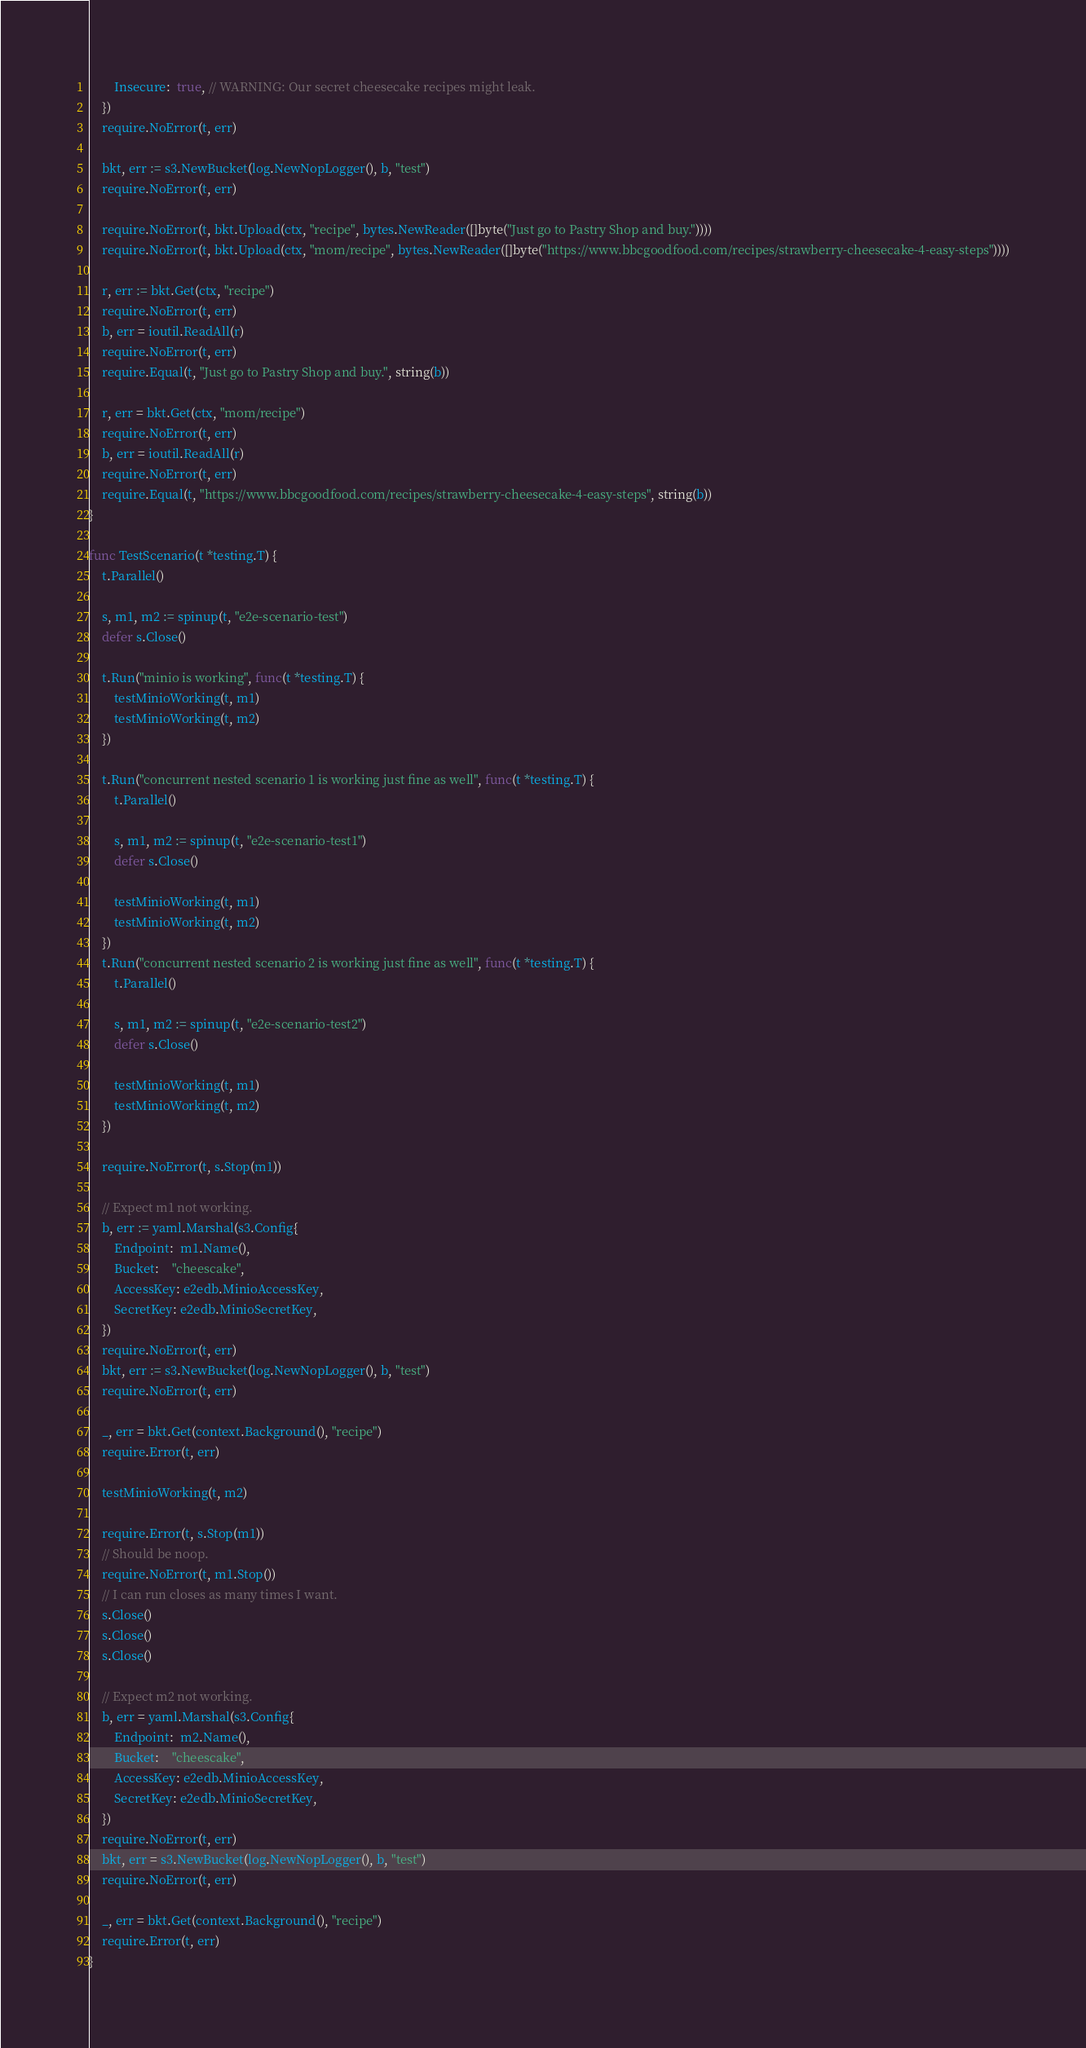Convert code to text. <code><loc_0><loc_0><loc_500><loc_500><_Go_>		Insecure:  true, // WARNING: Our secret cheesecake recipes might leak.
	})
	require.NoError(t, err)

	bkt, err := s3.NewBucket(log.NewNopLogger(), b, "test")
	require.NoError(t, err)

	require.NoError(t, bkt.Upload(ctx, "recipe", bytes.NewReader([]byte("Just go to Pastry Shop and buy."))))
	require.NoError(t, bkt.Upload(ctx, "mom/recipe", bytes.NewReader([]byte("https://www.bbcgoodfood.com/recipes/strawberry-cheesecake-4-easy-steps"))))

	r, err := bkt.Get(ctx, "recipe")
	require.NoError(t, err)
	b, err = ioutil.ReadAll(r)
	require.NoError(t, err)
	require.Equal(t, "Just go to Pastry Shop and buy.", string(b))

	r, err = bkt.Get(ctx, "mom/recipe")
	require.NoError(t, err)
	b, err = ioutil.ReadAll(r)
	require.NoError(t, err)
	require.Equal(t, "https://www.bbcgoodfood.com/recipes/strawberry-cheesecake-4-easy-steps", string(b))
}

func TestScenario(t *testing.T) {
	t.Parallel()

	s, m1, m2 := spinup(t, "e2e-scenario-test")
	defer s.Close()

	t.Run("minio is working", func(t *testing.T) {
		testMinioWorking(t, m1)
		testMinioWorking(t, m2)
	})

	t.Run("concurrent nested scenario 1 is working just fine as well", func(t *testing.T) {
		t.Parallel()

		s, m1, m2 := spinup(t, "e2e-scenario-test1")
		defer s.Close()

		testMinioWorking(t, m1)
		testMinioWorking(t, m2)
	})
	t.Run("concurrent nested scenario 2 is working just fine as well", func(t *testing.T) {
		t.Parallel()

		s, m1, m2 := spinup(t, "e2e-scenario-test2")
		defer s.Close()

		testMinioWorking(t, m1)
		testMinioWorking(t, m2)
	})

	require.NoError(t, s.Stop(m1))

	// Expect m1 not working.
	b, err := yaml.Marshal(s3.Config{
		Endpoint:  m1.Name(),
		Bucket:    "cheescake",
		AccessKey: e2edb.MinioAccessKey,
		SecretKey: e2edb.MinioSecretKey,
	})
	require.NoError(t, err)
	bkt, err := s3.NewBucket(log.NewNopLogger(), b, "test")
	require.NoError(t, err)

	_, err = bkt.Get(context.Background(), "recipe")
	require.Error(t, err)

	testMinioWorking(t, m2)

	require.Error(t, s.Stop(m1))
	// Should be noop.
	require.NoError(t, m1.Stop())
	// I can run closes as many times I want.
	s.Close()
	s.Close()
	s.Close()

	// Expect m2 not working.
	b, err = yaml.Marshal(s3.Config{
		Endpoint:  m2.Name(),
		Bucket:    "cheescake",
		AccessKey: e2edb.MinioAccessKey,
		SecretKey: e2edb.MinioSecretKey,
	})
	require.NoError(t, err)
	bkt, err = s3.NewBucket(log.NewNopLogger(), b, "test")
	require.NoError(t, err)

	_, err = bkt.Get(context.Background(), "recipe")
	require.Error(t, err)
}
</code> 